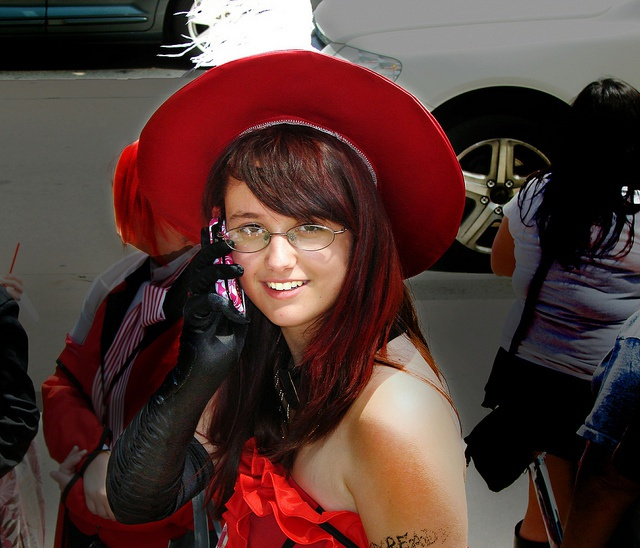Describe the objects in this image and their specific colors. I can see people in black, maroon, and gray tones, people in black, gray, and maroon tones, car in black and gray tones, people in black, maroon, and gray tones, and handbag in black and gray tones in this image. 